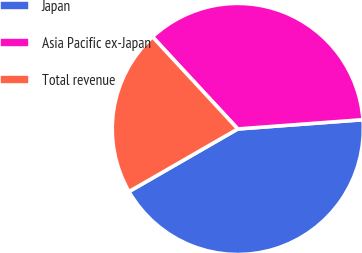<chart> <loc_0><loc_0><loc_500><loc_500><pie_chart><fcel>Japan<fcel>Asia Pacific ex-Japan<fcel>Total revenue<nl><fcel>42.86%<fcel>35.71%<fcel>21.43%<nl></chart> 